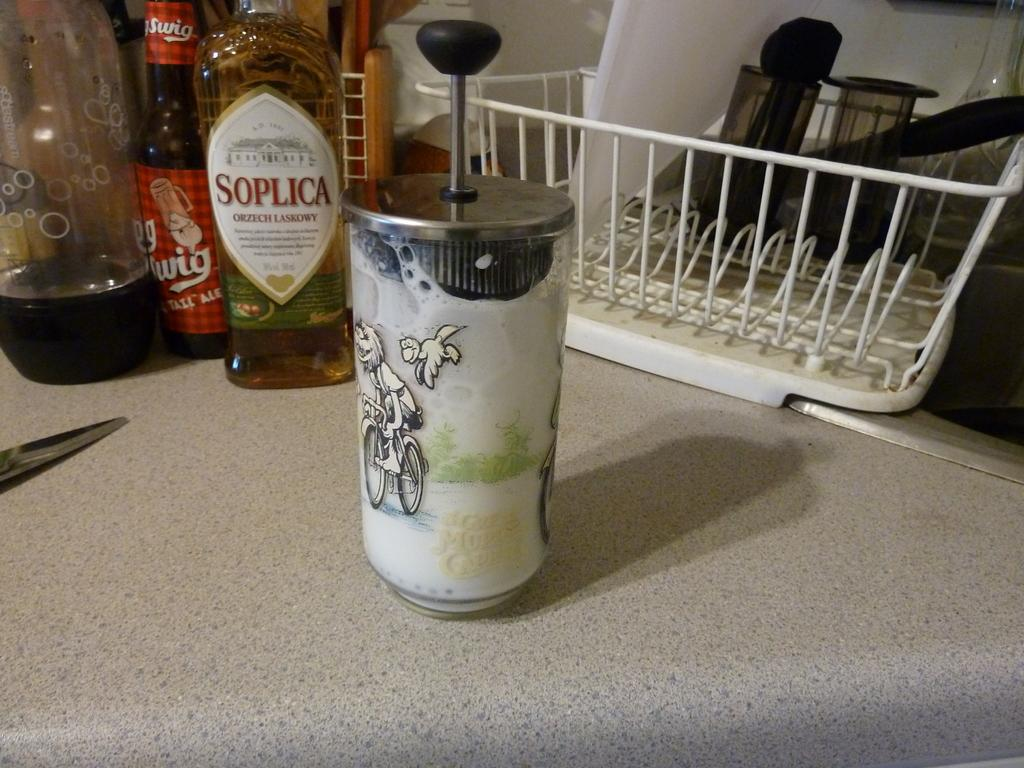What is on the table in the image? There is a glass, bottles, and a basket on the table. Can you describe the glass in the image? The glass is on the table. What else is on the table besides the glass? There are bottles and a basket on the table. How much does the pain weigh in the image? There is no pain present in the image, so it cannot be weighed. 